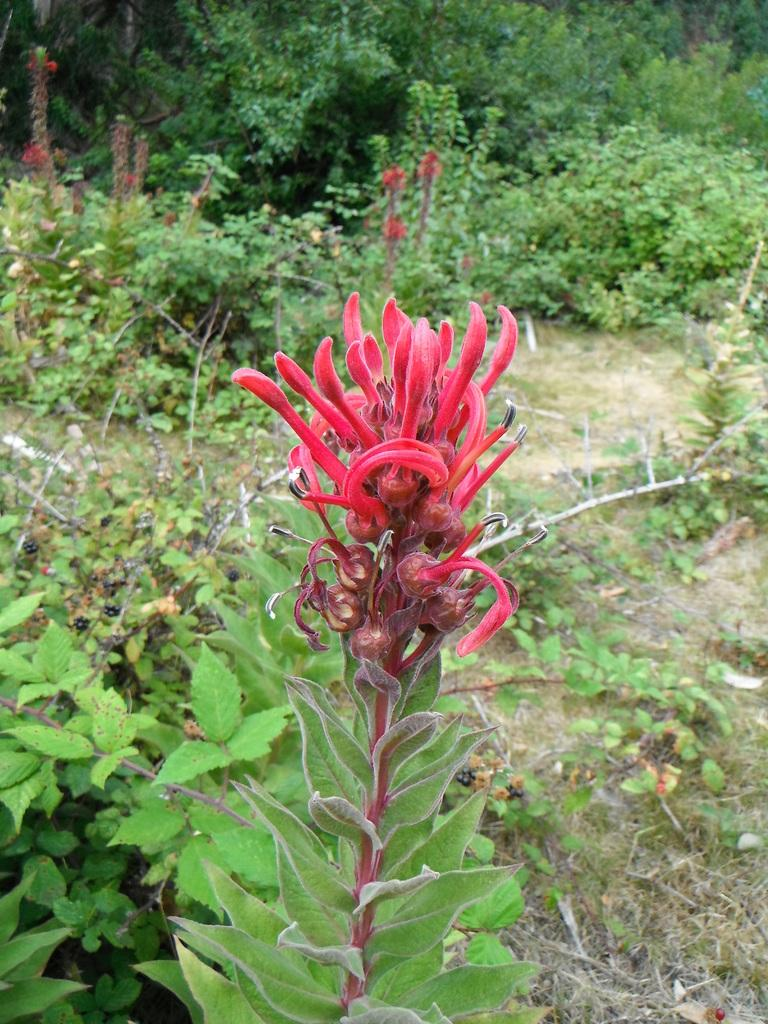What is the color of the plant in the foreground of the image? The plant in the foreground of the image is red-colored. What can be seen in the background of the image? There are plants and sticks on the ground in the background of the image. How many rings are visible on the plant in the image? There are no rings visible on the plant in the image, as it is a plant and not an object with rings. 